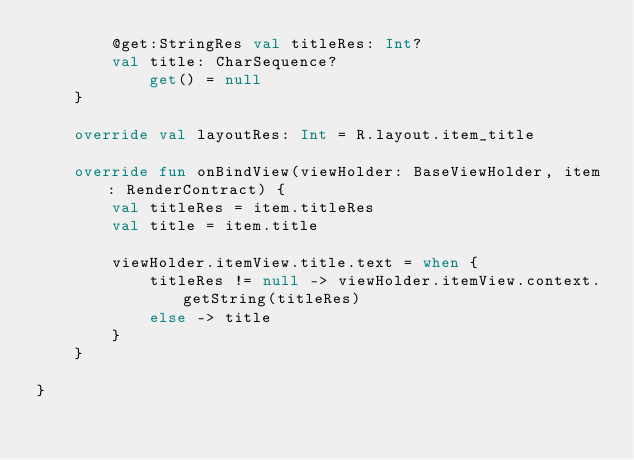Convert code to text. <code><loc_0><loc_0><loc_500><loc_500><_Kotlin_>        @get:StringRes val titleRes: Int?
        val title: CharSequence?
            get() = null
    }

    override val layoutRes: Int = R.layout.item_title

    override fun onBindView(viewHolder: BaseViewHolder, item: RenderContract) {
        val titleRes = item.titleRes
        val title = item.title

        viewHolder.itemView.title.text = when {
            titleRes != null -> viewHolder.itemView.context.getString(titleRes)
            else -> title
        }
    }

}</code> 